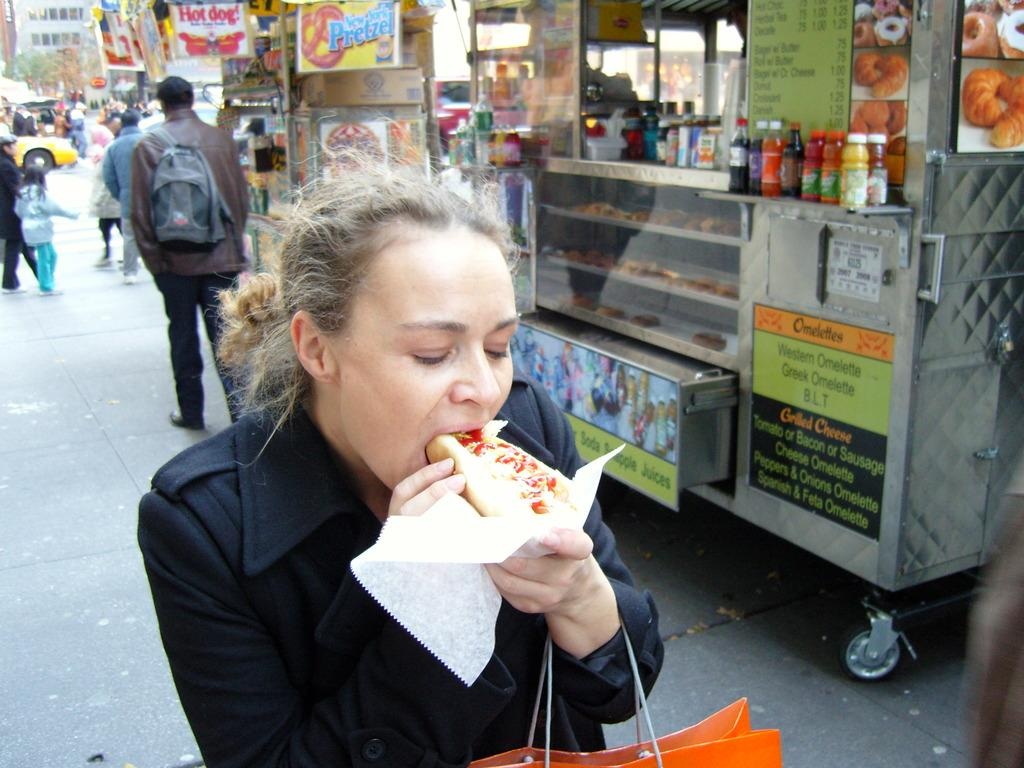<image>
Relay a brief, clear account of the picture shown. A woman enjoys a hot dog in front of a food cart offering grilled cheese, omelettes and other items. 